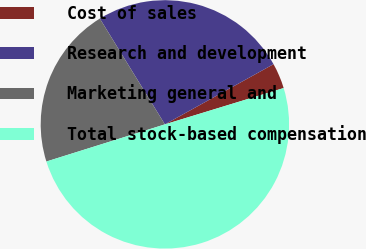Convert chart. <chart><loc_0><loc_0><loc_500><loc_500><pie_chart><fcel>Cost of sales<fcel>Research and development<fcel>Marketing general and<fcel>Total stock-based compensation<nl><fcel>3.33%<fcel>25.72%<fcel>21.06%<fcel>49.89%<nl></chart> 